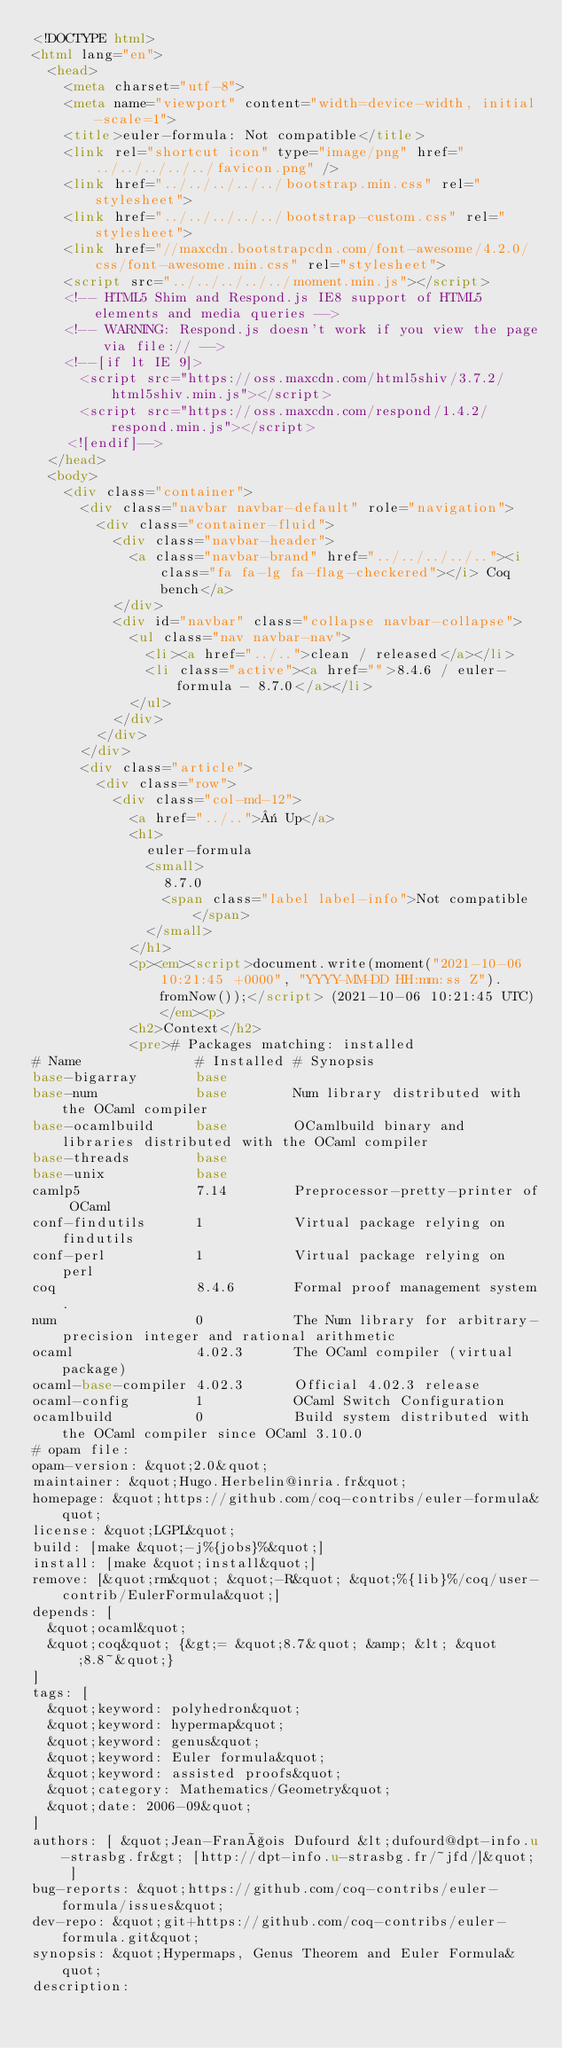<code> <loc_0><loc_0><loc_500><loc_500><_HTML_><!DOCTYPE html>
<html lang="en">
  <head>
    <meta charset="utf-8">
    <meta name="viewport" content="width=device-width, initial-scale=1">
    <title>euler-formula: Not compatible</title>
    <link rel="shortcut icon" type="image/png" href="../../../../../favicon.png" />
    <link href="../../../../../bootstrap.min.css" rel="stylesheet">
    <link href="../../../../../bootstrap-custom.css" rel="stylesheet">
    <link href="//maxcdn.bootstrapcdn.com/font-awesome/4.2.0/css/font-awesome.min.css" rel="stylesheet">
    <script src="../../../../../moment.min.js"></script>
    <!-- HTML5 Shim and Respond.js IE8 support of HTML5 elements and media queries -->
    <!-- WARNING: Respond.js doesn't work if you view the page via file:// -->
    <!--[if lt IE 9]>
      <script src="https://oss.maxcdn.com/html5shiv/3.7.2/html5shiv.min.js"></script>
      <script src="https://oss.maxcdn.com/respond/1.4.2/respond.min.js"></script>
    <![endif]-->
  </head>
  <body>
    <div class="container">
      <div class="navbar navbar-default" role="navigation">
        <div class="container-fluid">
          <div class="navbar-header">
            <a class="navbar-brand" href="../../../../.."><i class="fa fa-lg fa-flag-checkered"></i> Coq bench</a>
          </div>
          <div id="navbar" class="collapse navbar-collapse">
            <ul class="nav navbar-nav">
              <li><a href="../..">clean / released</a></li>
              <li class="active"><a href="">8.4.6 / euler-formula - 8.7.0</a></li>
            </ul>
          </div>
        </div>
      </div>
      <div class="article">
        <div class="row">
          <div class="col-md-12">
            <a href="../..">« Up</a>
            <h1>
              euler-formula
              <small>
                8.7.0
                <span class="label label-info">Not compatible</span>
              </small>
            </h1>
            <p><em><script>document.write(moment("2021-10-06 10:21:45 +0000", "YYYY-MM-DD HH:mm:ss Z").fromNow());</script> (2021-10-06 10:21:45 UTC)</em><p>
            <h2>Context</h2>
            <pre># Packages matching: installed
# Name              # Installed # Synopsis
base-bigarray       base
base-num            base        Num library distributed with the OCaml compiler
base-ocamlbuild     base        OCamlbuild binary and libraries distributed with the OCaml compiler
base-threads        base
base-unix           base
camlp5              7.14        Preprocessor-pretty-printer of OCaml
conf-findutils      1           Virtual package relying on findutils
conf-perl           1           Virtual package relying on perl
coq                 8.4.6       Formal proof management system.
num                 0           The Num library for arbitrary-precision integer and rational arithmetic
ocaml               4.02.3      The OCaml compiler (virtual package)
ocaml-base-compiler 4.02.3      Official 4.02.3 release
ocaml-config        1           OCaml Switch Configuration
ocamlbuild          0           Build system distributed with the OCaml compiler since OCaml 3.10.0
# opam file:
opam-version: &quot;2.0&quot;
maintainer: &quot;Hugo.Herbelin@inria.fr&quot;
homepage: &quot;https://github.com/coq-contribs/euler-formula&quot;
license: &quot;LGPL&quot;
build: [make &quot;-j%{jobs}%&quot;]
install: [make &quot;install&quot;]
remove: [&quot;rm&quot; &quot;-R&quot; &quot;%{lib}%/coq/user-contrib/EulerFormula&quot;]
depends: [
  &quot;ocaml&quot;
  &quot;coq&quot; {&gt;= &quot;8.7&quot; &amp; &lt; &quot;8.8~&quot;}
]
tags: [
  &quot;keyword: polyhedron&quot;
  &quot;keyword: hypermap&quot;
  &quot;keyword: genus&quot;
  &quot;keyword: Euler formula&quot;
  &quot;keyword: assisted proofs&quot;
  &quot;category: Mathematics/Geometry&quot;
  &quot;date: 2006-09&quot;
]
authors: [ &quot;Jean-François Dufourd &lt;dufourd@dpt-info.u-strasbg.fr&gt; [http://dpt-info.u-strasbg.fr/~jfd/]&quot; ]
bug-reports: &quot;https://github.com/coq-contribs/euler-formula/issues&quot;
dev-repo: &quot;git+https://github.com/coq-contribs/euler-formula.git&quot;
synopsis: &quot;Hypermaps, Genus Theorem and Euler Formula&quot;
description:</code> 